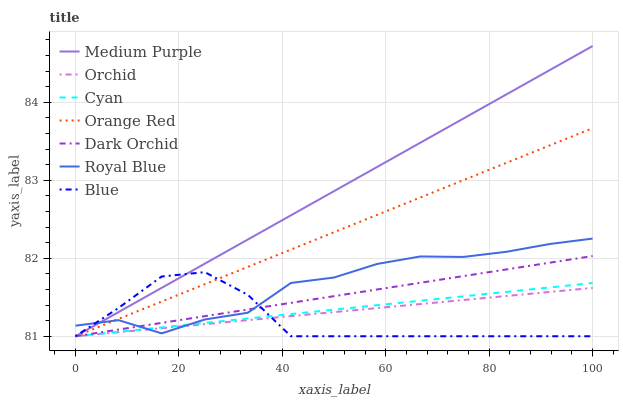Does Dark Orchid have the minimum area under the curve?
Answer yes or no. No. Does Dark Orchid have the maximum area under the curve?
Answer yes or no. No. Is Dark Orchid the smoothest?
Answer yes or no. No. Is Dark Orchid the roughest?
Answer yes or no. No. Does Royal Blue have the lowest value?
Answer yes or no. No. Does Dark Orchid have the highest value?
Answer yes or no. No. 